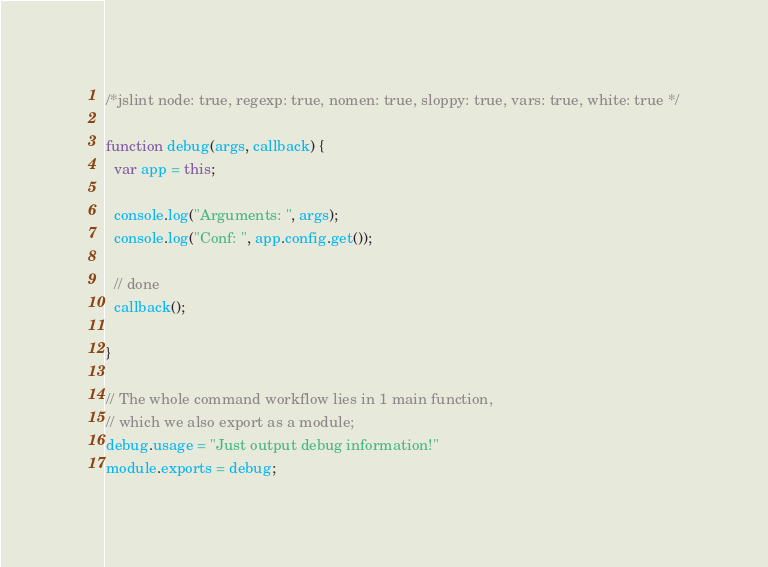Convert code to text. <code><loc_0><loc_0><loc_500><loc_500><_JavaScript_>/*jslint node: true, regexp: true, nomen: true, sloppy: true, vars: true, white: true */

function debug(args, callback) {
  var app = this;
  
  console.log("Arguments: ", args);
  console.log("Conf: ", app.config.get());
  
  // done
  callback();
  
}

// The whole command workflow lies in 1 main function,
// which we also export as a module;
debug.usage = "Just output debug information!"
module.exports = debug;
</code> 